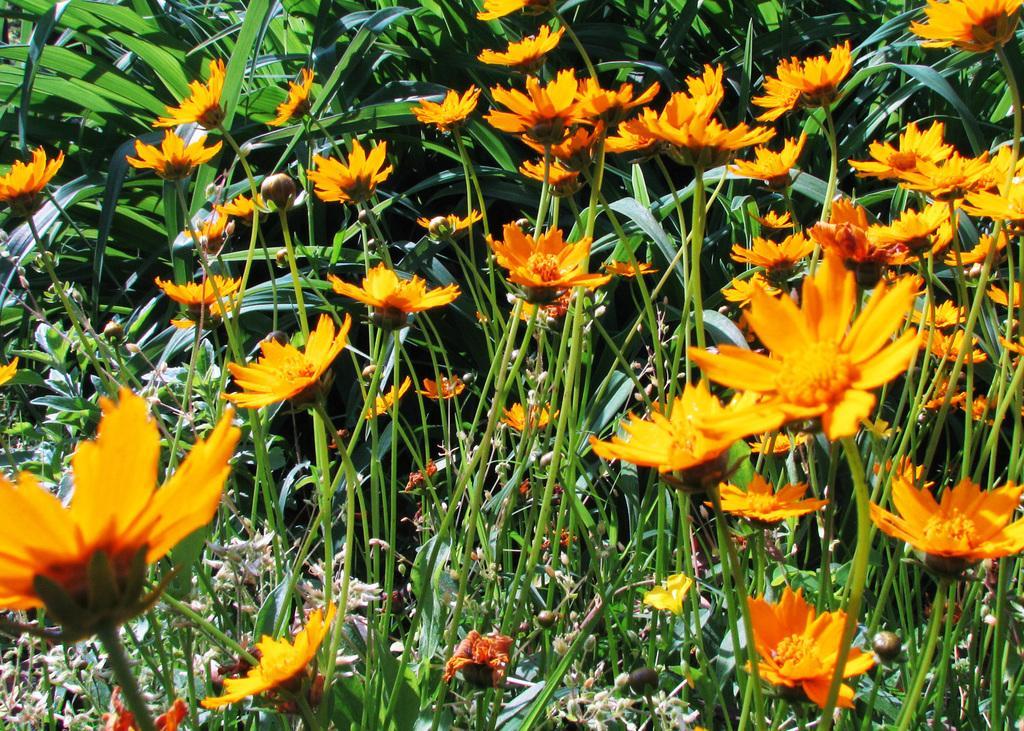Could you give a brief overview of what you see in this image? To these plants there are flowers. These are green leaves. 